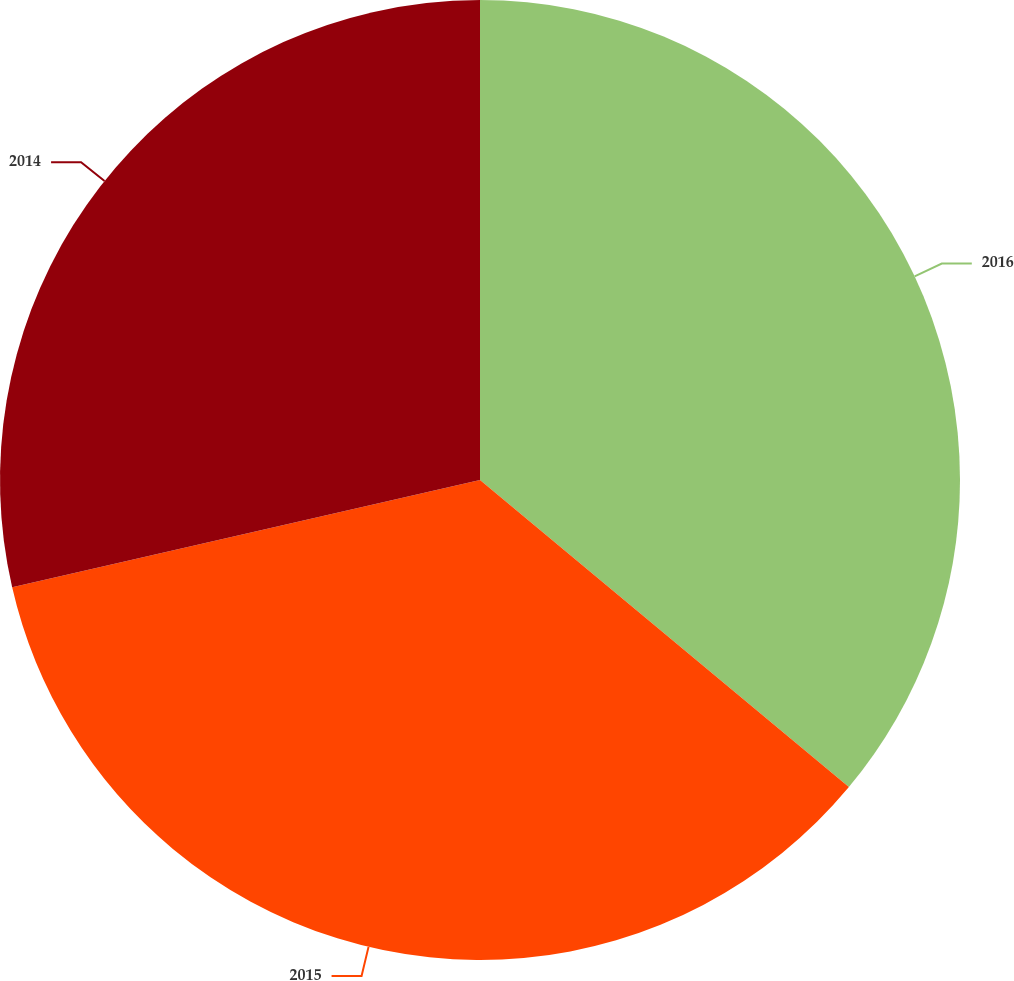Convert chart. <chart><loc_0><loc_0><loc_500><loc_500><pie_chart><fcel>2016<fcel>2015<fcel>2014<nl><fcel>36.05%<fcel>35.36%<fcel>28.59%<nl></chart> 